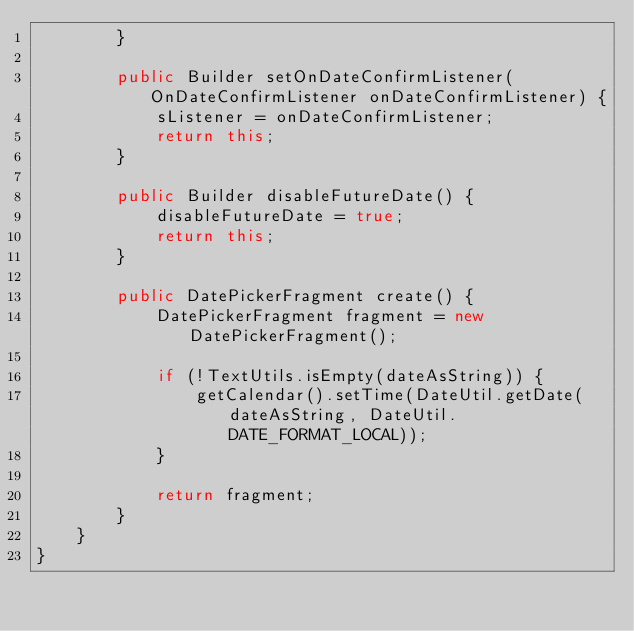<code> <loc_0><loc_0><loc_500><loc_500><_Java_>        }

        public Builder setOnDateConfirmListener(OnDateConfirmListener onDateConfirmListener) {
            sListener = onDateConfirmListener;
            return this;
        }

        public Builder disableFutureDate() {
            disableFutureDate = true;
            return this;
        }

        public DatePickerFragment create() {
            DatePickerFragment fragment = new DatePickerFragment();

            if (!TextUtils.isEmpty(dateAsString)) {
                getCalendar().setTime(DateUtil.getDate(dateAsString, DateUtil.DATE_FORMAT_LOCAL));
            }

            return fragment;
        }
    }
}</code> 